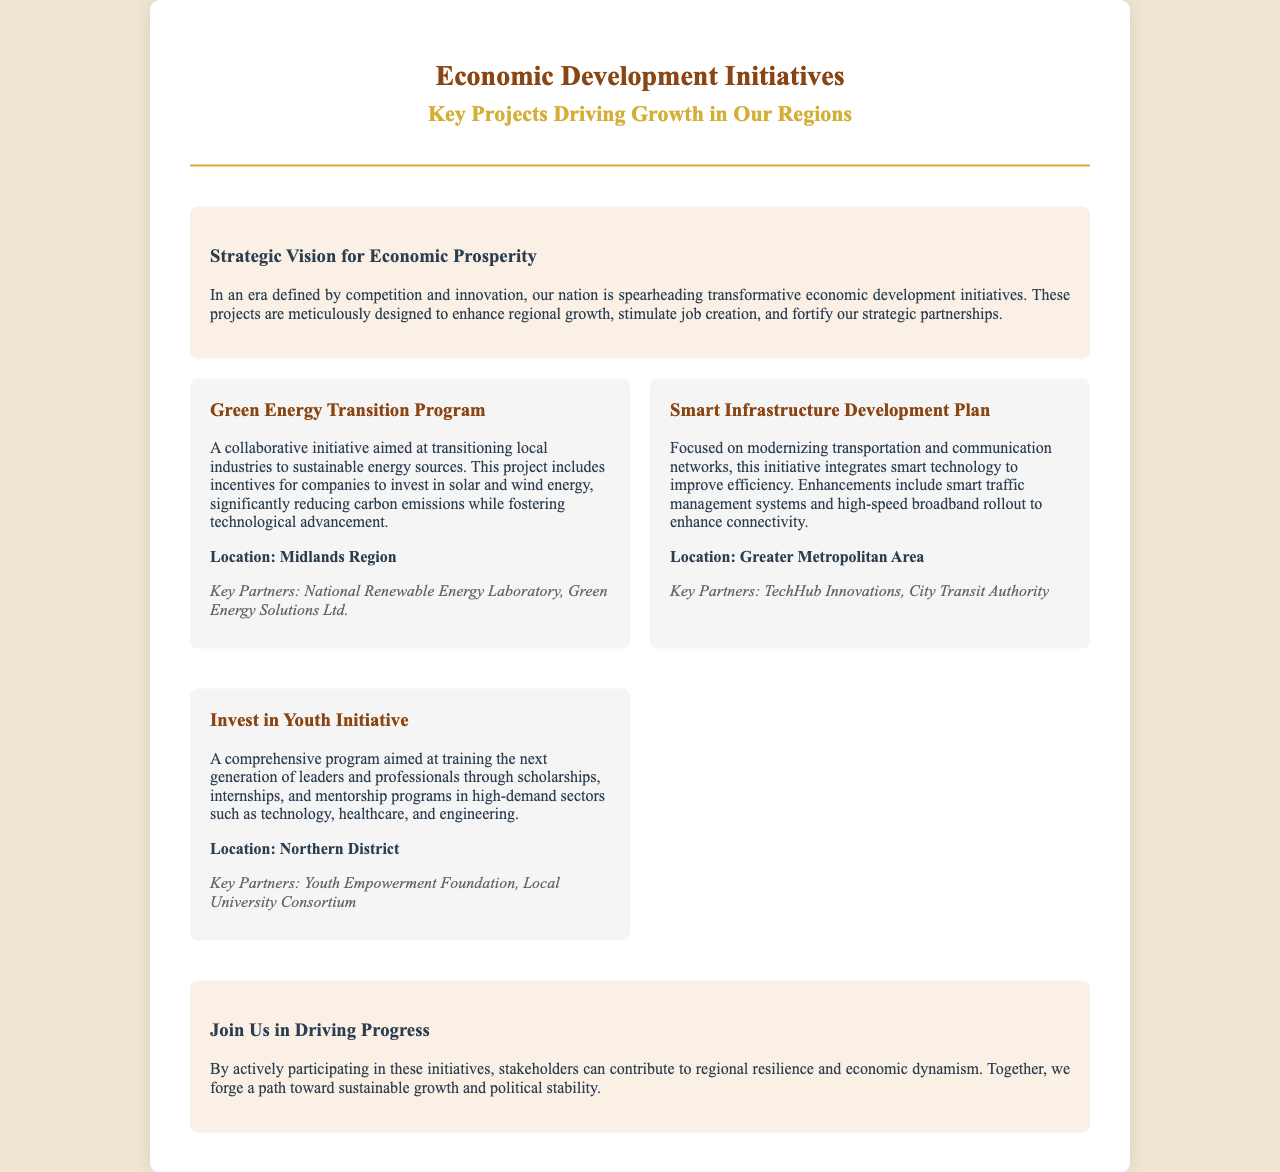What is the title of the brochure? The title reflects the central theme of the document, which covers economic initiatives.
Answer: Economic Development Initiatives What is the main goal of the Strategic Vision for Economic Prosperity section? This section describes the overarching intent behind the initiatives introduced in the brochure.
Answer: Enhance regional growth What region is the Green Energy Transition Program located in? The location of the project is explicitly stated in the brochure.
Answer: Midlands Region Who are the key partners in the Smart Infrastructure Development Plan? The brochure specifies partnerships that support the initiative.
Answer: TechHub Innovations, City Transit Authority What type of training does the Invest in Youth Initiative focus on? This initiative aims to prepare individuals for specific careers and sectors.
Answer: Scholarships, internships, mentorship programs What are the technological improvements mentioned in the Smart Infrastructure Development Plan? The brochure highlights specific enhancements under this initiative.
Answer: Smart traffic management systems and high-speed broadband What is the focus of the Invest in Youth Initiative? This question explores the primary target audience or aspect of the initiative described.
Answer: Training the next generation of leaders What does the conclusion encourage stakeholders to do? The conclusion suggests a collective action for economic development and stability.
Answer: Actively participating in these initiatives 